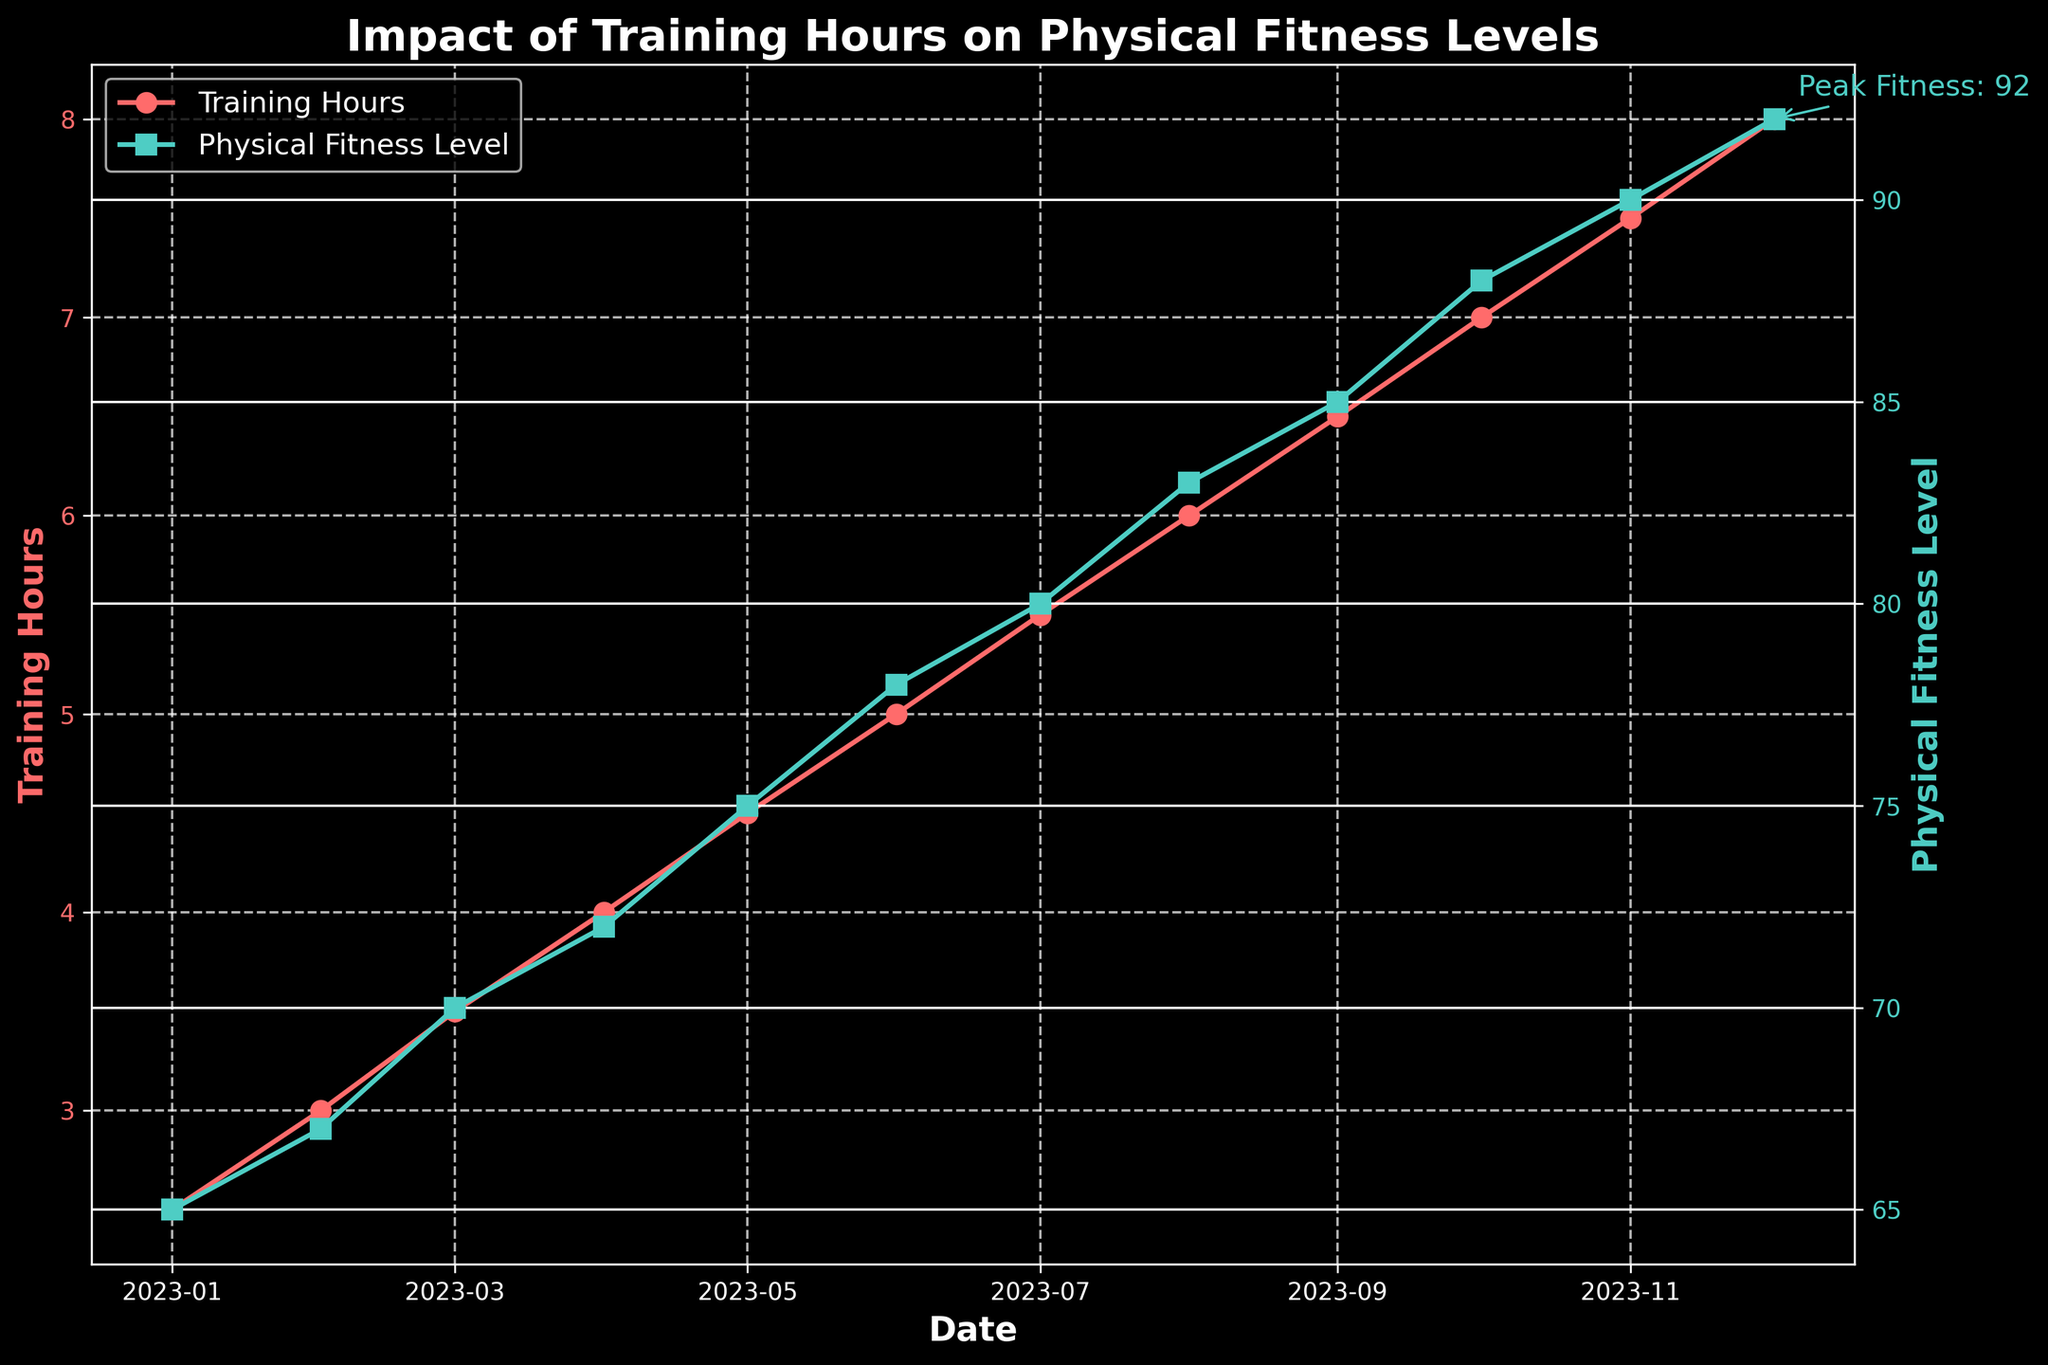What is the title of the figure? The title of the figure is a text element usually located at the top of a plot. It serves to describe the main topic or theme that the plot represents, which in this case is "Impact of Training Hours on Physical Fitness Levels."
Answer: Impact of Training Hours on Physical Fitness Levels What color is used for the Training Hours line? The color of the Training Hours line is visually represented and easily seen in the plot. According to the plot, the Training Hours line is red.
Answer: Red What date corresponds to the highest Physical Fitness Level? By observing the plot, we can see that the highest Physical Fitness Level data point is labeled with a text annotation. This data point occurs in December 2023.
Answer: December 2023 How many data points are there in total? By counting the markers on both lines or the x-ticks, we see that each month has one data point, spanning from January to December 2023.
Answer: 12 Is the trend for Physical Fitness Level increasing or decreasing? By visually following the Physical Fitness Level line from left to right, we observe that the line consistently rises from start to end, indicating an increasing trend.
Answer: Increasing What is the difference in Physical Fitness Levels between January and December? The Physical Fitness Level in January is 65 and in December it's 92. The difference is calculated by subtracting the level in January from that in December: 92 - 65 = 27.
Answer: 27 What is the average Training Hours per month for the year? To find the average Training Hours per month, sum all the monthly training hours and divide by the number of months. Sum: 2.5 + 3.0 + 3.5 + 4.0 + 4.5 + 5.0 + 5.5 + 6.0 + 6.5 + 7.0 + 7.5 + 8.0 = 63.5. Divide by 12: 63.5 / 12 ≈ 5.29.
Answer: Approximately 5.29 By how many units does the Physical Fitness Level increase for each additional Training Hour, on average? To determine how Physical Fitness Level changes with Training Hours, calculate the difference in Physical Fitness Level and divide by the difference in Training Hours. Difference in Fitness Level: 92 - 65 = 27. Difference in Training Hours: 8.0 - 2.5 = 5.5. Increase per Hour: 27 / 5.5 ≈ 4.91 units.
Answer: Approximately 4.91 units Which month shows the most significant increase in Physical Fitness Level compared to the previous month? By inspecting the plot month-by-month, we observe that the largest vertical gap on the Physical Fitness Level line occurs between June (78) and July (80), corresponding to an increase of 3 units.
Answer: July What annotation is added to the plot and why? An annotation is a text marker directly added to the plot to highlight critical information. Here, the annotation marks the peak Physical Fitness Level of 92 in December.
Answer: Peak Fitness: 92 